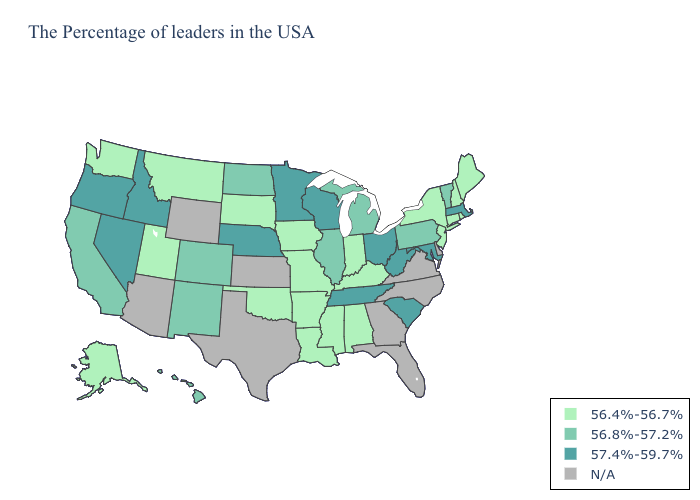Is the legend a continuous bar?
Concise answer only. No. Name the states that have a value in the range 56.8%-57.2%?
Give a very brief answer. Vermont, Pennsylvania, Michigan, Illinois, North Dakota, Colorado, New Mexico, California, Hawaii. Name the states that have a value in the range 56.4%-56.7%?
Write a very short answer. Maine, Rhode Island, New Hampshire, Connecticut, New York, New Jersey, Kentucky, Indiana, Alabama, Mississippi, Louisiana, Missouri, Arkansas, Iowa, Oklahoma, South Dakota, Utah, Montana, Washington, Alaska. Does Maryland have the lowest value in the South?
Write a very short answer. No. Name the states that have a value in the range 56.4%-56.7%?
Concise answer only. Maine, Rhode Island, New Hampshire, Connecticut, New York, New Jersey, Kentucky, Indiana, Alabama, Mississippi, Louisiana, Missouri, Arkansas, Iowa, Oklahoma, South Dakota, Utah, Montana, Washington, Alaska. How many symbols are there in the legend?
Answer briefly. 4. Name the states that have a value in the range 57.4%-59.7%?
Keep it brief. Massachusetts, Maryland, South Carolina, West Virginia, Ohio, Tennessee, Wisconsin, Minnesota, Nebraska, Idaho, Nevada, Oregon. Which states hav the highest value in the West?
Answer briefly. Idaho, Nevada, Oregon. What is the value of California?
Keep it brief. 56.8%-57.2%. Does California have the lowest value in the West?
Short answer required. No. Does Maryland have the highest value in the South?
Be succinct. Yes. What is the value of Nevada?
Short answer required. 57.4%-59.7%. What is the value of Idaho?
Concise answer only. 57.4%-59.7%. Does Mississippi have the lowest value in the South?
Write a very short answer. Yes. Name the states that have a value in the range N/A?
Write a very short answer. Delaware, Virginia, North Carolina, Florida, Georgia, Kansas, Texas, Wyoming, Arizona. 